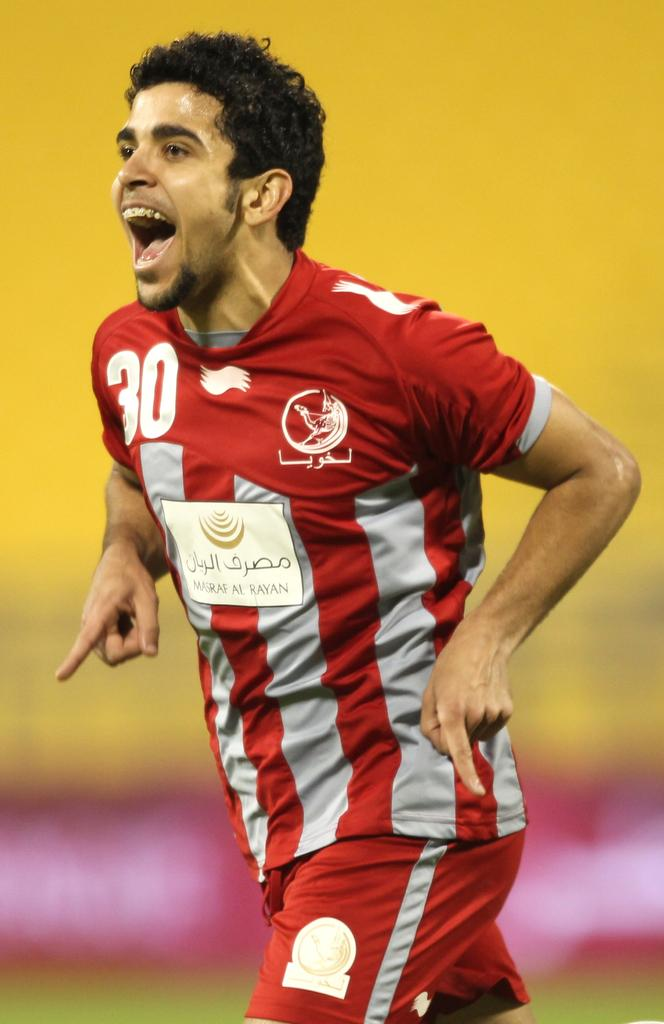<image>
Offer a succinct explanation of the picture presented. The number 30 player celebrates as he runs. 